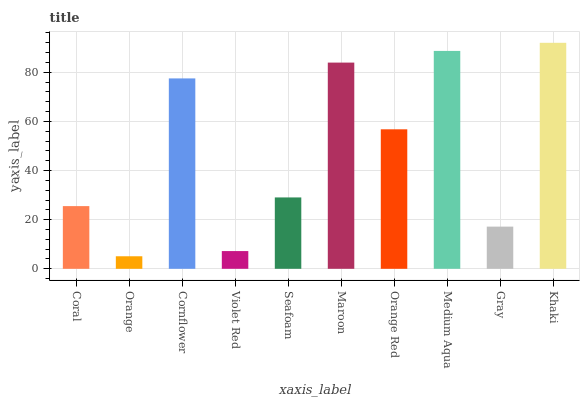Is Cornflower the minimum?
Answer yes or no. No. Is Cornflower the maximum?
Answer yes or no. No. Is Cornflower greater than Orange?
Answer yes or no. Yes. Is Orange less than Cornflower?
Answer yes or no. Yes. Is Orange greater than Cornflower?
Answer yes or no. No. Is Cornflower less than Orange?
Answer yes or no. No. Is Orange Red the high median?
Answer yes or no. Yes. Is Seafoam the low median?
Answer yes or no. Yes. Is Maroon the high median?
Answer yes or no. No. Is Orange the low median?
Answer yes or no. No. 